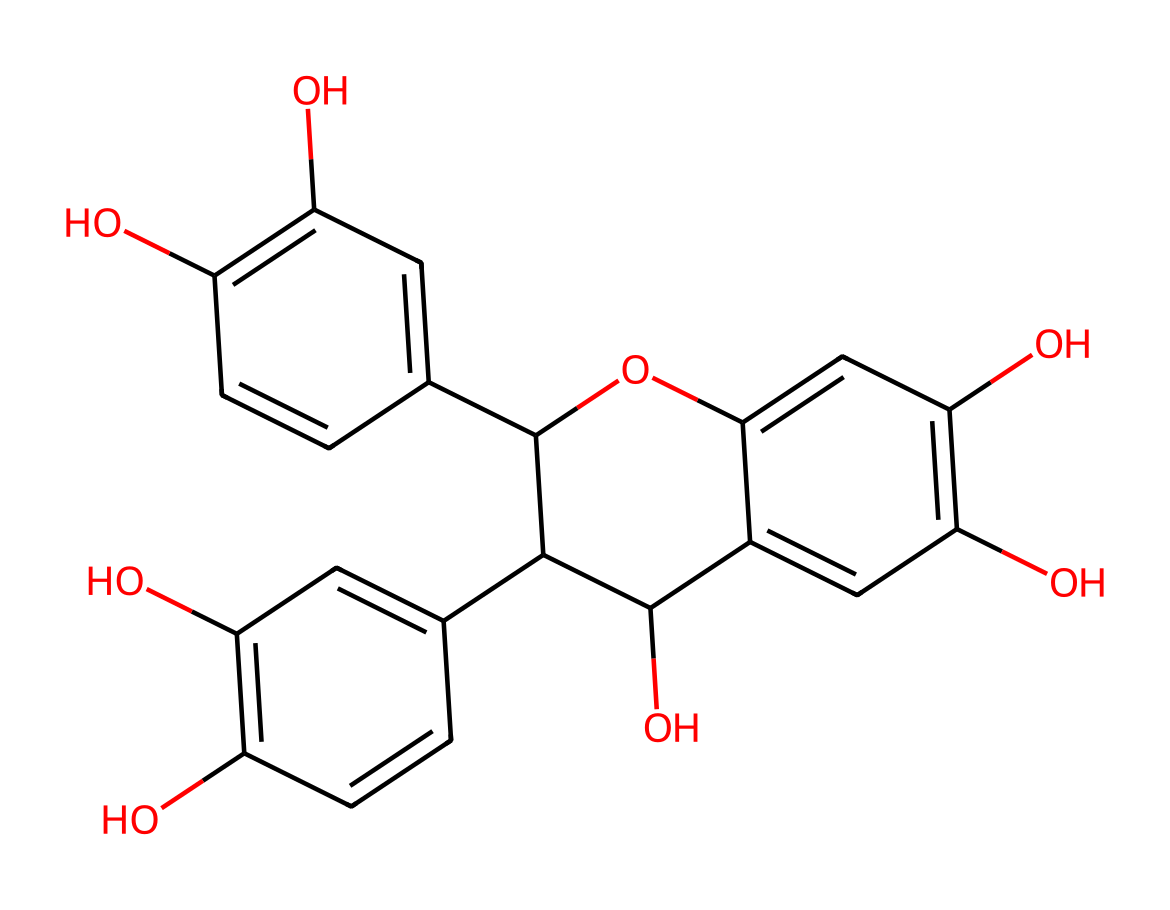What type of chemical structure is represented by this SMILES notation? The SMILES notation indicates a polyphenolic compound with multiple hydroxyl groups, typical of tannins. Tannins are known for their complex phenolic structures and ability to bind and precipitate proteins.
Answer: tannins How many hydroxyl groups are present in this molecule? By examining the structure represented in the SMILES, one can identify several -OH groups (hydroxyls) when counting each instance in the fragmentation of the chemical. Counting these gives a total of four -OH groups.
Answer: four What is the primary function of tannins in leather-making? Tannins are primarily used for their ability to bind proteins, which helps preserve and enhance the durability of leather. Their astringent properties also contribute to the tanning process, allowing for the transformation of raw hides into leather.
Answer: preserve Does this molecule contain any rings in its structure? The SMILES notation shows several cyclic structures, indicated by the opening and closing of the numbered rings (C1 and C2). This implies the presence of multiple aromatic rings typical for tannins, confirming that there are ring structures in the molecule.
Answer: yes What property of tannins contributes to their use in traditional leather-making? Tannins have astringent properties, which means they contract tissues and make them firmer; this helps in the tanning process by stabilizing collagen fibers in animal hides, providing longevity and resilience to finished leather.
Answer: astringent 